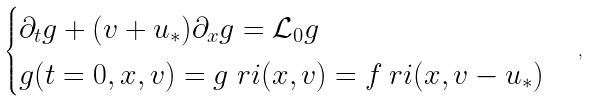Convert formula to latex. <formula><loc_0><loc_0><loc_500><loc_500>\begin{cases} \partial _ { t } g + ( v + u _ { \ast } ) \partial _ { x } g = \mathcal { L } _ { 0 } g \\ g ( t = 0 , x , v ) = g _ { \ } r i ( x , v ) = f _ { \ } r i ( x , v - u _ { \ast } ) \end{cases} \, ,</formula> 